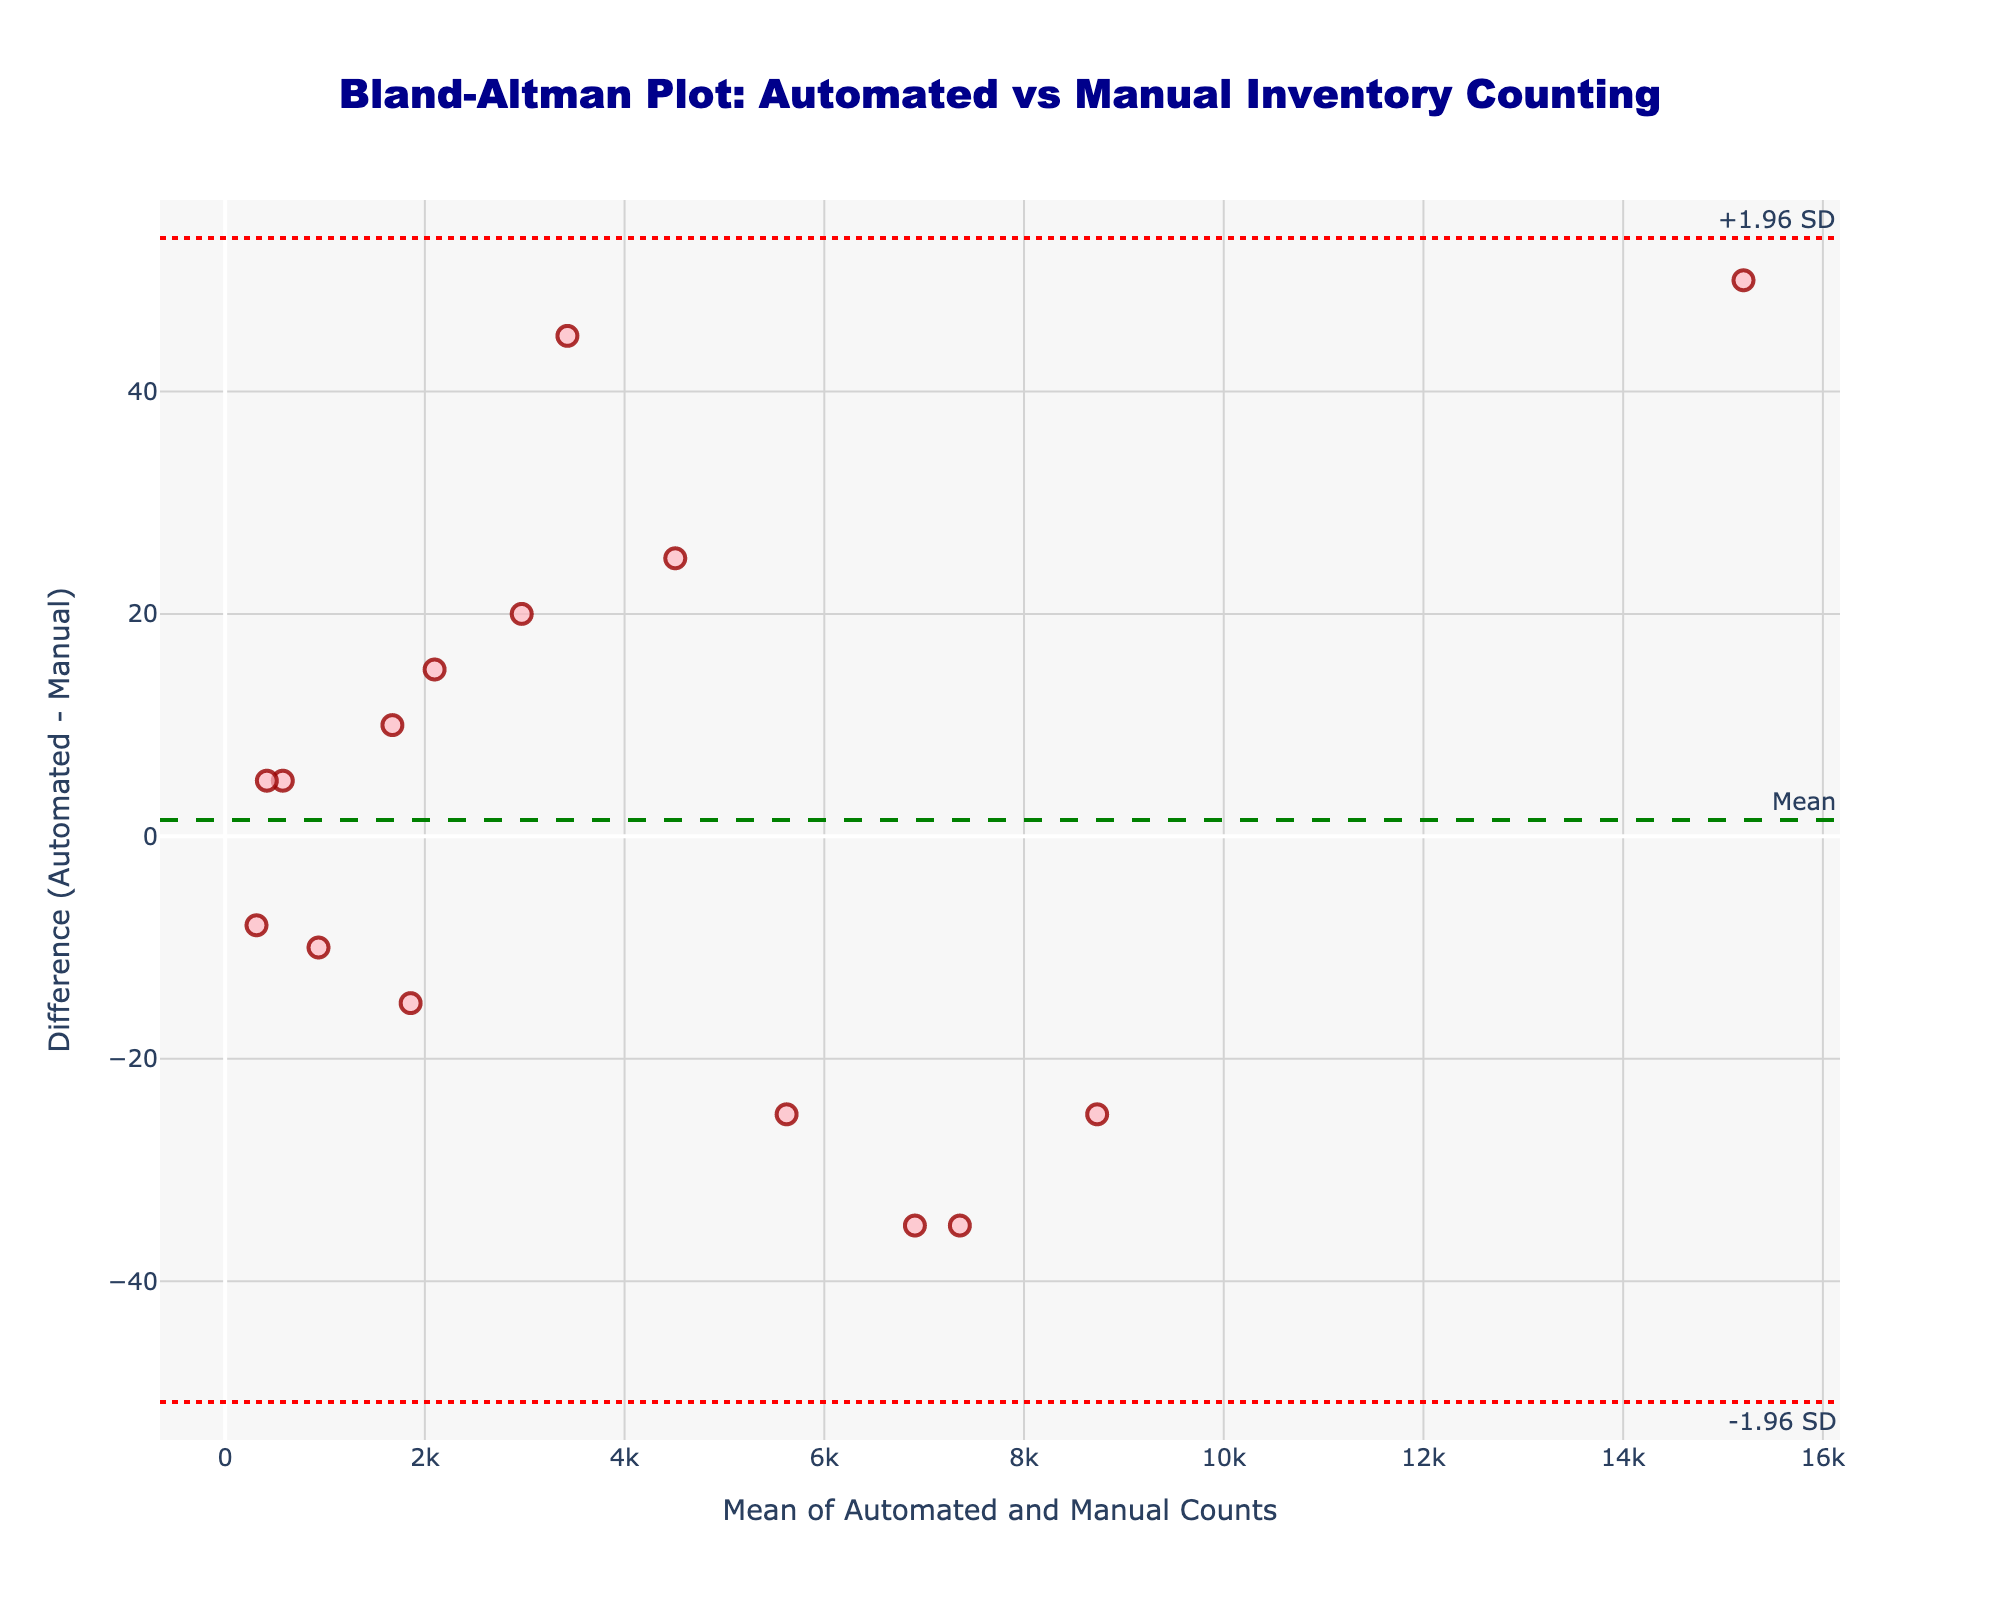What is the title of the plot? The title can be found at the top of the plot.
Answer: Bland-Altman Plot: Automated vs Manual Inventory Counting What are the x-axis and y-axis labels? The labels can be found along the axes of the plot. The x-axis label is at the bottom, and the y-axis label is to the left.
Answer: The x-axis label is "Mean of Automated and Manual Counts," and the y-axis label is "Difference (Automated - Manual)." How many data points are plotted in the figure? Count the number of markers on the plot.
Answer: 15 What is the mean difference between the automated and manual counts? The mean difference is shown as a dashed horizontal line, usually annotated.
Answer: The mean difference is the green dashed line labeled "Mean." What are the upper and lower limits of agreement? The limits of agreement are the dotted horizontal lines, usually annotated as "+1.96 SD" and "-1.96 SD."
Answer: The upper limit is "+1.96 SD," and the lower limit is "-1.96 SD." Which product category has the largest positive difference between automated and manual counts? Find the highest point above the zero line on the y-axis and check its corresponding x-axis value.
Answer: Work-in-Progress Are there any differences that fall outside the limits of agreement? Look at the plot to see if any markers are outside the dotted lines representing the limits of agreement.
Answer: No How does the mean difference compare to the zero line? Check if the green dashed line labeled "Mean" is above or below the horizontal axis line at zero.
Answer: The mean difference is above the zero line Is the assumption that the differences are normally distributed supported? This can be discerned by looking at the scatter plot; if the differences are evenly spread around the mean line without any cluster, it supports normal distribution.
Answer: Yes, the differences are evenly spread What does the spread of data points around the mean suggest about the consistency of automated counts compared to manual counts? A tight clustering around the mean line suggests high consistency, while a wider spread suggests variability.
Answer: The spread of data points suggests some variability in consistency 